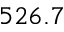<formula> <loc_0><loc_0><loc_500><loc_500>5 2 6 . 7</formula> 